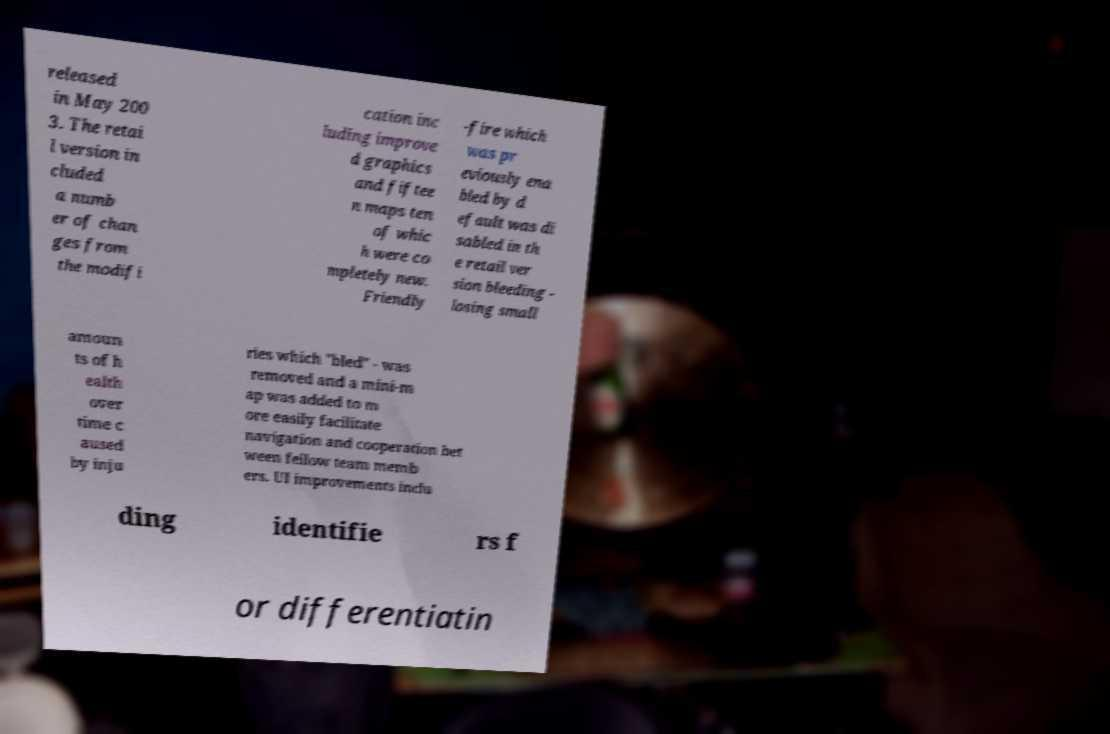Can you accurately transcribe the text from the provided image for me? released in May 200 3. The retai l version in cluded a numb er of chan ges from the modifi cation inc luding improve d graphics and fiftee n maps ten of whic h were co mpletely new. Friendly -fire which was pr eviously ena bled by d efault was di sabled in th e retail ver sion bleeding - losing small amoun ts of h ealth over time c aused by inju ries which "bled" - was removed and a mini-m ap was added to m ore easily facilitate navigation and cooperation bet ween fellow team memb ers. UI improvements inclu ding identifie rs f or differentiatin 